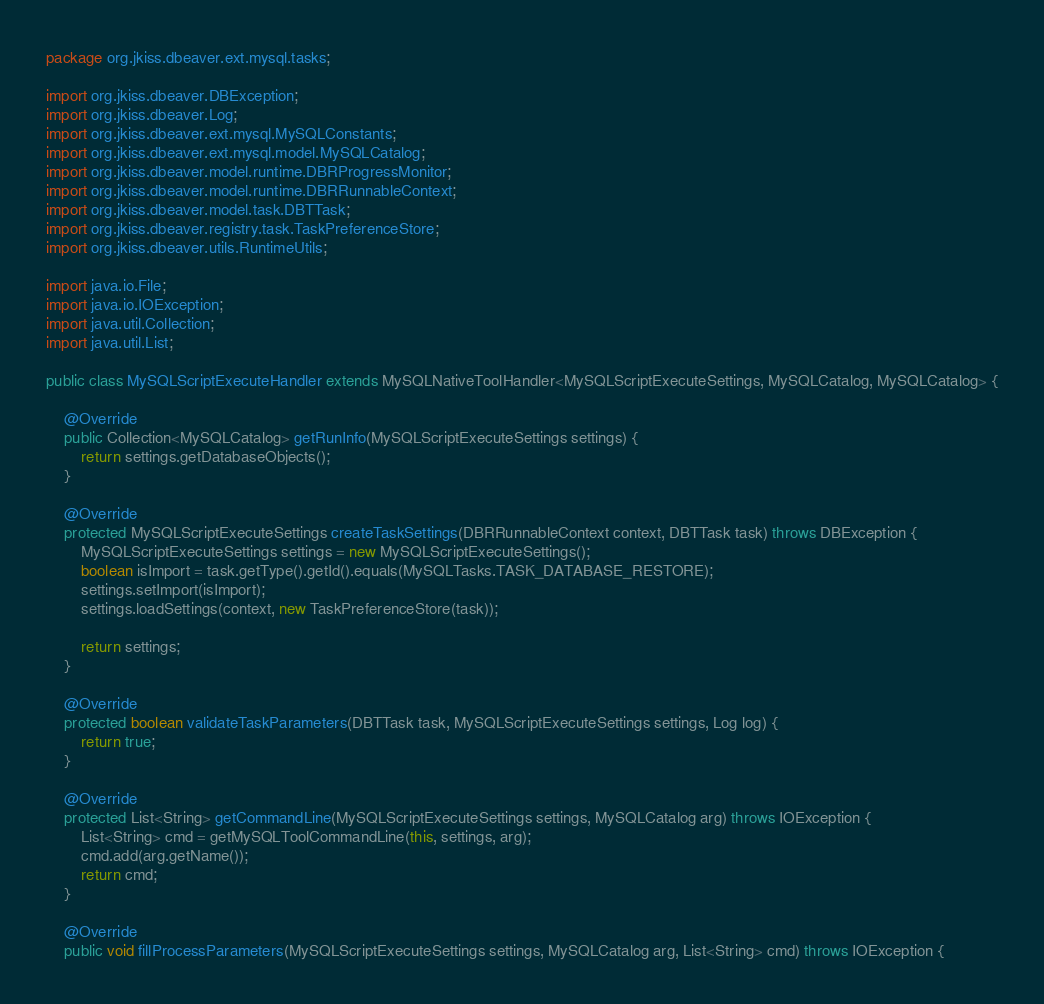Convert code to text. <code><loc_0><loc_0><loc_500><loc_500><_Java_>package org.jkiss.dbeaver.ext.mysql.tasks;

import org.jkiss.dbeaver.DBException;
import org.jkiss.dbeaver.Log;
import org.jkiss.dbeaver.ext.mysql.MySQLConstants;
import org.jkiss.dbeaver.ext.mysql.model.MySQLCatalog;
import org.jkiss.dbeaver.model.runtime.DBRProgressMonitor;
import org.jkiss.dbeaver.model.runtime.DBRRunnableContext;
import org.jkiss.dbeaver.model.task.DBTTask;
import org.jkiss.dbeaver.registry.task.TaskPreferenceStore;
import org.jkiss.dbeaver.utils.RuntimeUtils;

import java.io.File;
import java.io.IOException;
import java.util.Collection;
import java.util.List;

public class MySQLScriptExecuteHandler extends MySQLNativeToolHandler<MySQLScriptExecuteSettings, MySQLCatalog, MySQLCatalog> {

    @Override
    public Collection<MySQLCatalog> getRunInfo(MySQLScriptExecuteSettings settings) {
        return settings.getDatabaseObjects();
    }

    @Override
    protected MySQLScriptExecuteSettings createTaskSettings(DBRRunnableContext context, DBTTask task) throws DBException {
        MySQLScriptExecuteSettings settings = new MySQLScriptExecuteSettings();
        boolean isImport = task.getType().getId().equals(MySQLTasks.TASK_DATABASE_RESTORE);
        settings.setImport(isImport);
        settings.loadSettings(context, new TaskPreferenceStore(task));

        return settings;
    }

    @Override
    protected boolean validateTaskParameters(DBTTask task, MySQLScriptExecuteSettings settings, Log log) {
        return true;
    }

    @Override
    protected List<String> getCommandLine(MySQLScriptExecuteSettings settings, MySQLCatalog arg) throws IOException {
        List<String> cmd = getMySQLToolCommandLine(this, settings, arg);
        cmd.add(arg.getName());
        return cmd;
    }

    @Override
    public void fillProcessParameters(MySQLScriptExecuteSettings settings, MySQLCatalog arg, List<String> cmd) throws IOException {</code> 